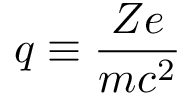<formula> <loc_0><loc_0><loc_500><loc_500>q \equiv \frac { Z e } { m c ^ { 2 } }</formula> 